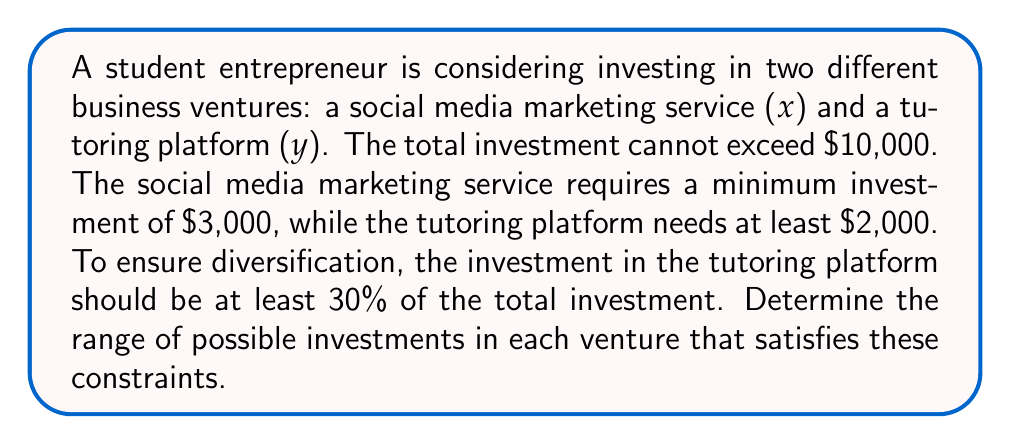Can you solve this math problem? Let's approach this step-by-step using a system of inequalities:

1) First, let's define our variables:
   x = investment in social media marketing service
   y = investment in tutoring platform

2) Now, let's translate the constraints into inequalities:
   a) Total investment constraint: $x + y \leq 10000$
   b) Minimum investment for social media marketing: $x \geq 3000$
   c) Minimum investment for tutoring platform: $y \geq 2000$
   d) Diversification requirement: $y \geq 0.3(x + y)$

3) Let's simplify the diversification requirement:
   $y \geq 0.3x + 0.3y$
   $0.7y \geq 0.3x$
   $y \geq \frac{3}{7}x$

4) Our system of inequalities is now:
   $$\begin{cases}
   x + y \leq 10000 \\
   x \geq 3000 \\
   y \geq 2000 \\
   y \geq \frac{3}{7}x
   \end{cases}$$

5) To visualize this, we could graph these inequalities. The feasible region would be the area that satisfies all these constraints.

6) To find the range of possible investments, we need to find the extreme points:
   - Minimum x: $3000 (given)
   - Maximum x: When y is at its minimum (2000), x = 10000 - 2000 = 8000
   - Minimum y: $2000 (given)
   - Maximum y: When x is at its minimum (3000), y = 10000 - 3000 = 7000

7) However, we need to check if these extremes satisfy the diversification requirement:
   For minimum x and maximum y: $7000 > \frac{3}{7}(3000) = 1285.71$, so this is valid.
   For maximum x and minimum y: $2000 < \frac{3}{7}(8000) = 3428.57$, so this is not valid.

8) To find the actual maximum x, we solve:
   $y = \frac{3}{7}x$ and $x + y = 10000$
   $x + \frac{3}{7}x = 10000$
   $\frac{10}{7}x = 10000$
   $x = 7000$

Therefore, the range of possible investments is:
$3000 \leq x \leq 7000$
$2000 \leq y \leq 7000$
Answer: $3000 \leq x \leq 7000$, $2000 \leq y \leq 7000$ 